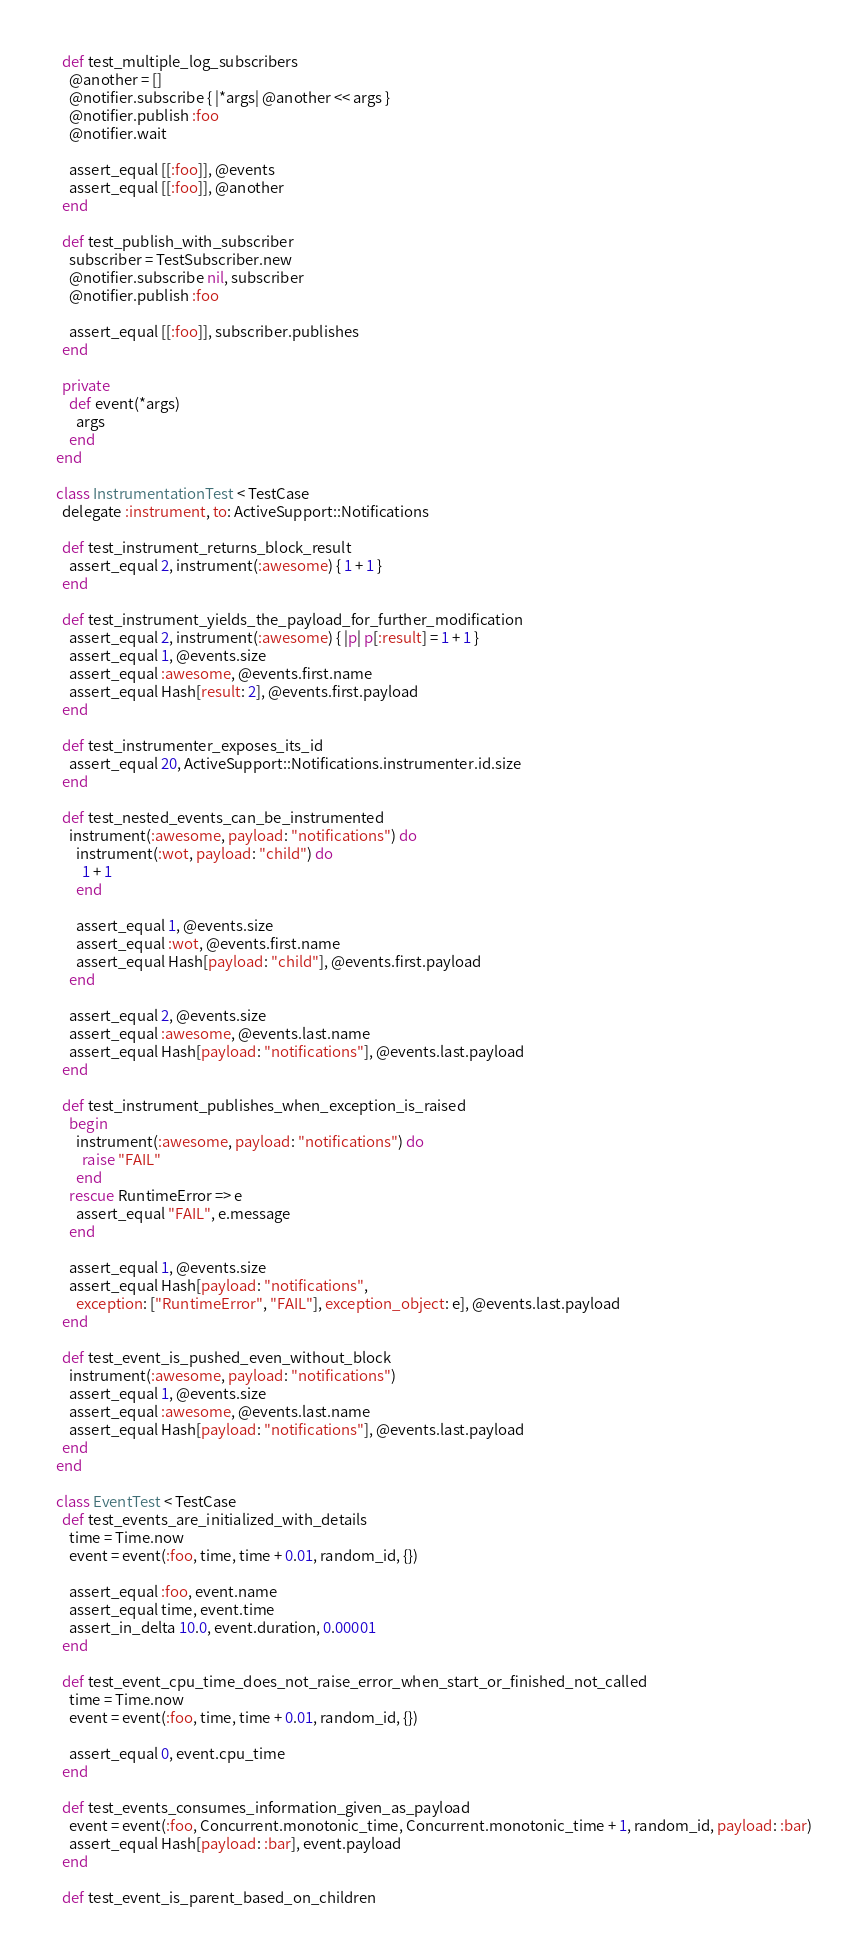Convert code to text. <code><loc_0><loc_0><loc_500><loc_500><_Ruby_>
    def test_multiple_log_subscribers
      @another = []
      @notifier.subscribe { |*args| @another << args }
      @notifier.publish :foo
      @notifier.wait

      assert_equal [[:foo]], @events
      assert_equal [[:foo]], @another
    end

    def test_publish_with_subscriber
      subscriber = TestSubscriber.new
      @notifier.subscribe nil, subscriber
      @notifier.publish :foo

      assert_equal [[:foo]], subscriber.publishes
    end

    private
      def event(*args)
        args
      end
  end

  class InstrumentationTest < TestCase
    delegate :instrument, to: ActiveSupport::Notifications

    def test_instrument_returns_block_result
      assert_equal 2, instrument(:awesome) { 1 + 1 }
    end

    def test_instrument_yields_the_payload_for_further_modification
      assert_equal 2, instrument(:awesome) { |p| p[:result] = 1 + 1 }
      assert_equal 1, @events.size
      assert_equal :awesome, @events.first.name
      assert_equal Hash[result: 2], @events.first.payload
    end

    def test_instrumenter_exposes_its_id
      assert_equal 20, ActiveSupport::Notifications.instrumenter.id.size
    end

    def test_nested_events_can_be_instrumented
      instrument(:awesome, payload: "notifications") do
        instrument(:wot, payload: "child") do
          1 + 1
        end

        assert_equal 1, @events.size
        assert_equal :wot, @events.first.name
        assert_equal Hash[payload: "child"], @events.first.payload
      end

      assert_equal 2, @events.size
      assert_equal :awesome, @events.last.name
      assert_equal Hash[payload: "notifications"], @events.last.payload
    end

    def test_instrument_publishes_when_exception_is_raised
      begin
        instrument(:awesome, payload: "notifications") do
          raise "FAIL"
        end
      rescue RuntimeError => e
        assert_equal "FAIL", e.message
      end

      assert_equal 1, @events.size
      assert_equal Hash[payload: "notifications",
        exception: ["RuntimeError", "FAIL"], exception_object: e], @events.last.payload
    end

    def test_event_is_pushed_even_without_block
      instrument(:awesome, payload: "notifications")
      assert_equal 1, @events.size
      assert_equal :awesome, @events.last.name
      assert_equal Hash[payload: "notifications"], @events.last.payload
    end
  end

  class EventTest < TestCase
    def test_events_are_initialized_with_details
      time = Time.now
      event = event(:foo, time, time + 0.01, random_id, {})

      assert_equal :foo, event.name
      assert_equal time, event.time
      assert_in_delta 10.0, event.duration, 0.00001
    end

    def test_event_cpu_time_does_not_raise_error_when_start_or_finished_not_called
      time = Time.now
      event = event(:foo, time, time + 0.01, random_id, {})

      assert_equal 0, event.cpu_time
    end

    def test_events_consumes_information_given_as_payload
      event = event(:foo, Concurrent.monotonic_time, Concurrent.monotonic_time + 1, random_id, payload: :bar)
      assert_equal Hash[payload: :bar], event.payload
    end

    def test_event_is_parent_based_on_children</code> 